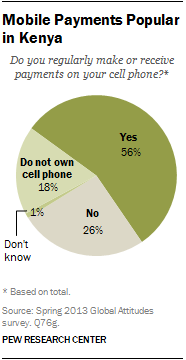Give some essential details in this illustration. According to the data, 56% of respondents reported receiving payment on their cell phone. The pie chart shows the percentage of different segments, and one of the segments has a value of 26%. 